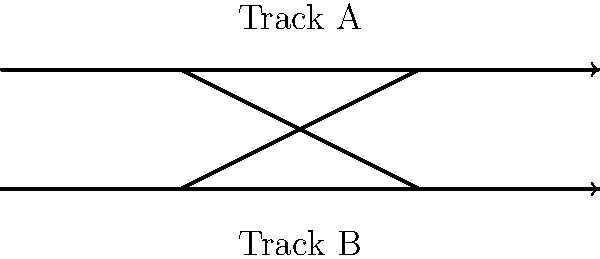As a railway enthusiast, you're studying different track layouts. The diagram shows a common configuration used in many railway systems. What is the name of this track layout, and what is its primary function in railway operations? To identify this track layout and understand its function, let's analyze the diagram step-by-step:

1. We can see two parallel main tracks running horizontally.
2. There are two diagonal tracks connecting these main tracks.
3. The diagonal tracks form an "X" shape between the main tracks.
4. This configuration allows trains to switch from one track to another.

This layout is known as a "double crossover" or "scissors crossover." Its primary functions are:

1. Flexibility: It allows trains to switch between parallel tracks in either direction.
2. Operational efficiency: Trains can change tracks without stopping or reversing.
3. Maintenance: It enables one track to be closed for maintenance while still allowing bi-directional traffic on the other track.
4. Capacity: It increases the overall capacity of the line by allowing more flexible routing of trains.

In railway history, this layout became increasingly important with the growth of rail networks and the need for more complex traffic management, especially in busy corridors or near stations.
Answer: Double crossover; allows trains to switch between parallel tracks in either direction 